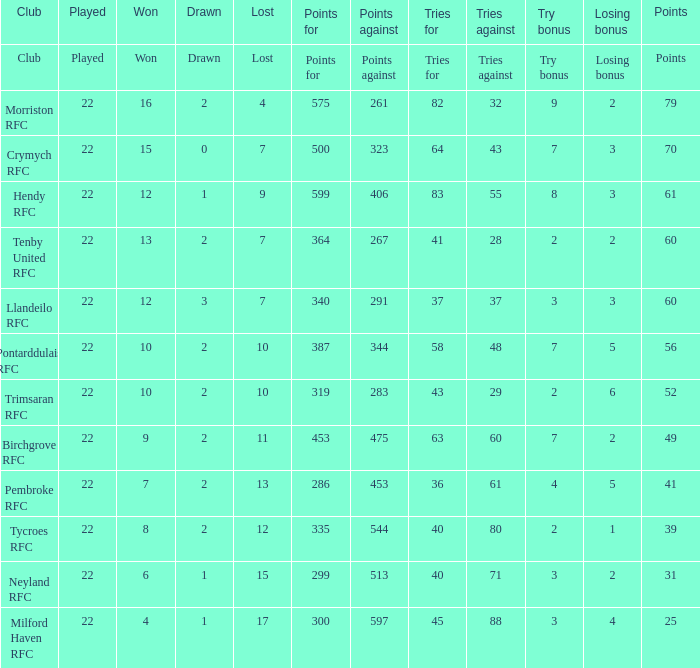Help me parse the entirety of this table. {'header': ['Club', 'Played', 'Won', 'Drawn', 'Lost', 'Points for', 'Points against', 'Tries for', 'Tries against', 'Try bonus', 'Losing bonus', 'Points'], 'rows': [['Club', 'Played', 'Won', 'Drawn', 'Lost', 'Points for', 'Points against', 'Tries for', 'Tries against', 'Try bonus', 'Losing bonus', 'Points'], ['Morriston RFC', '22', '16', '2', '4', '575', '261', '82', '32', '9', '2', '79'], ['Crymych RFC', '22', '15', '0', '7', '500', '323', '64', '43', '7', '3', '70'], ['Hendy RFC', '22', '12', '1', '9', '599', '406', '83', '55', '8', '3', '61'], ['Tenby United RFC', '22', '13', '2', '7', '364', '267', '41', '28', '2', '2', '60'], ['Llandeilo RFC', '22', '12', '3', '7', '340', '291', '37', '37', '3', '3', '60'], ['Pontarddulais RFC', '22', '10', '2', '10', '387', '344', '58', '48', '7', '5', '56'], ['Trimsaran RFC', '22', '10', '2', '10', '319', '283', '43', '29', '2', '6', '52'], ['Birchgrove RFC', '22', '9', '2', '11', '453', '475', '63', '60', '7', '2', '49'], ['Pembroke RFC', '22', '7', '2', '13', '286', '453', '36', '61', '4', '5', '41'], ['Tycroes RFC', '22', '8', '2', '12', '335', '544', '40', '80', '2', '1', '39'], ['Neyland RFC', '22', '6', '1', '15', '299', '513', '40', '71', '3', '2', '31'], ['Milford Haven RFC', '22', '4', '1', '17', '300', '597', '45', '88', '3', '4', '25']]} In relation to tries, what is the point breakdown for reaching 64? 70.0. 